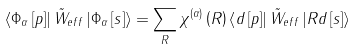Convert formula to latex. <formula><loc_0><loc_0><loc_500><loc_500>\left \langle \Phi _ { \alpha } \left [ p \right ] \right | \tilde { W } _ { e f f } \left | \Phi _ { \alpha } \left [ s \right ] \right \rangle = \sum _ { R } \chi ^ { \left ( \alpha \right ) } \left ( R \right ) \left \langle d \left [ p \right ] \right | \tilde { W } _ { e f f } \left | R d \left [ s \right ] \right \rangle</formula> 